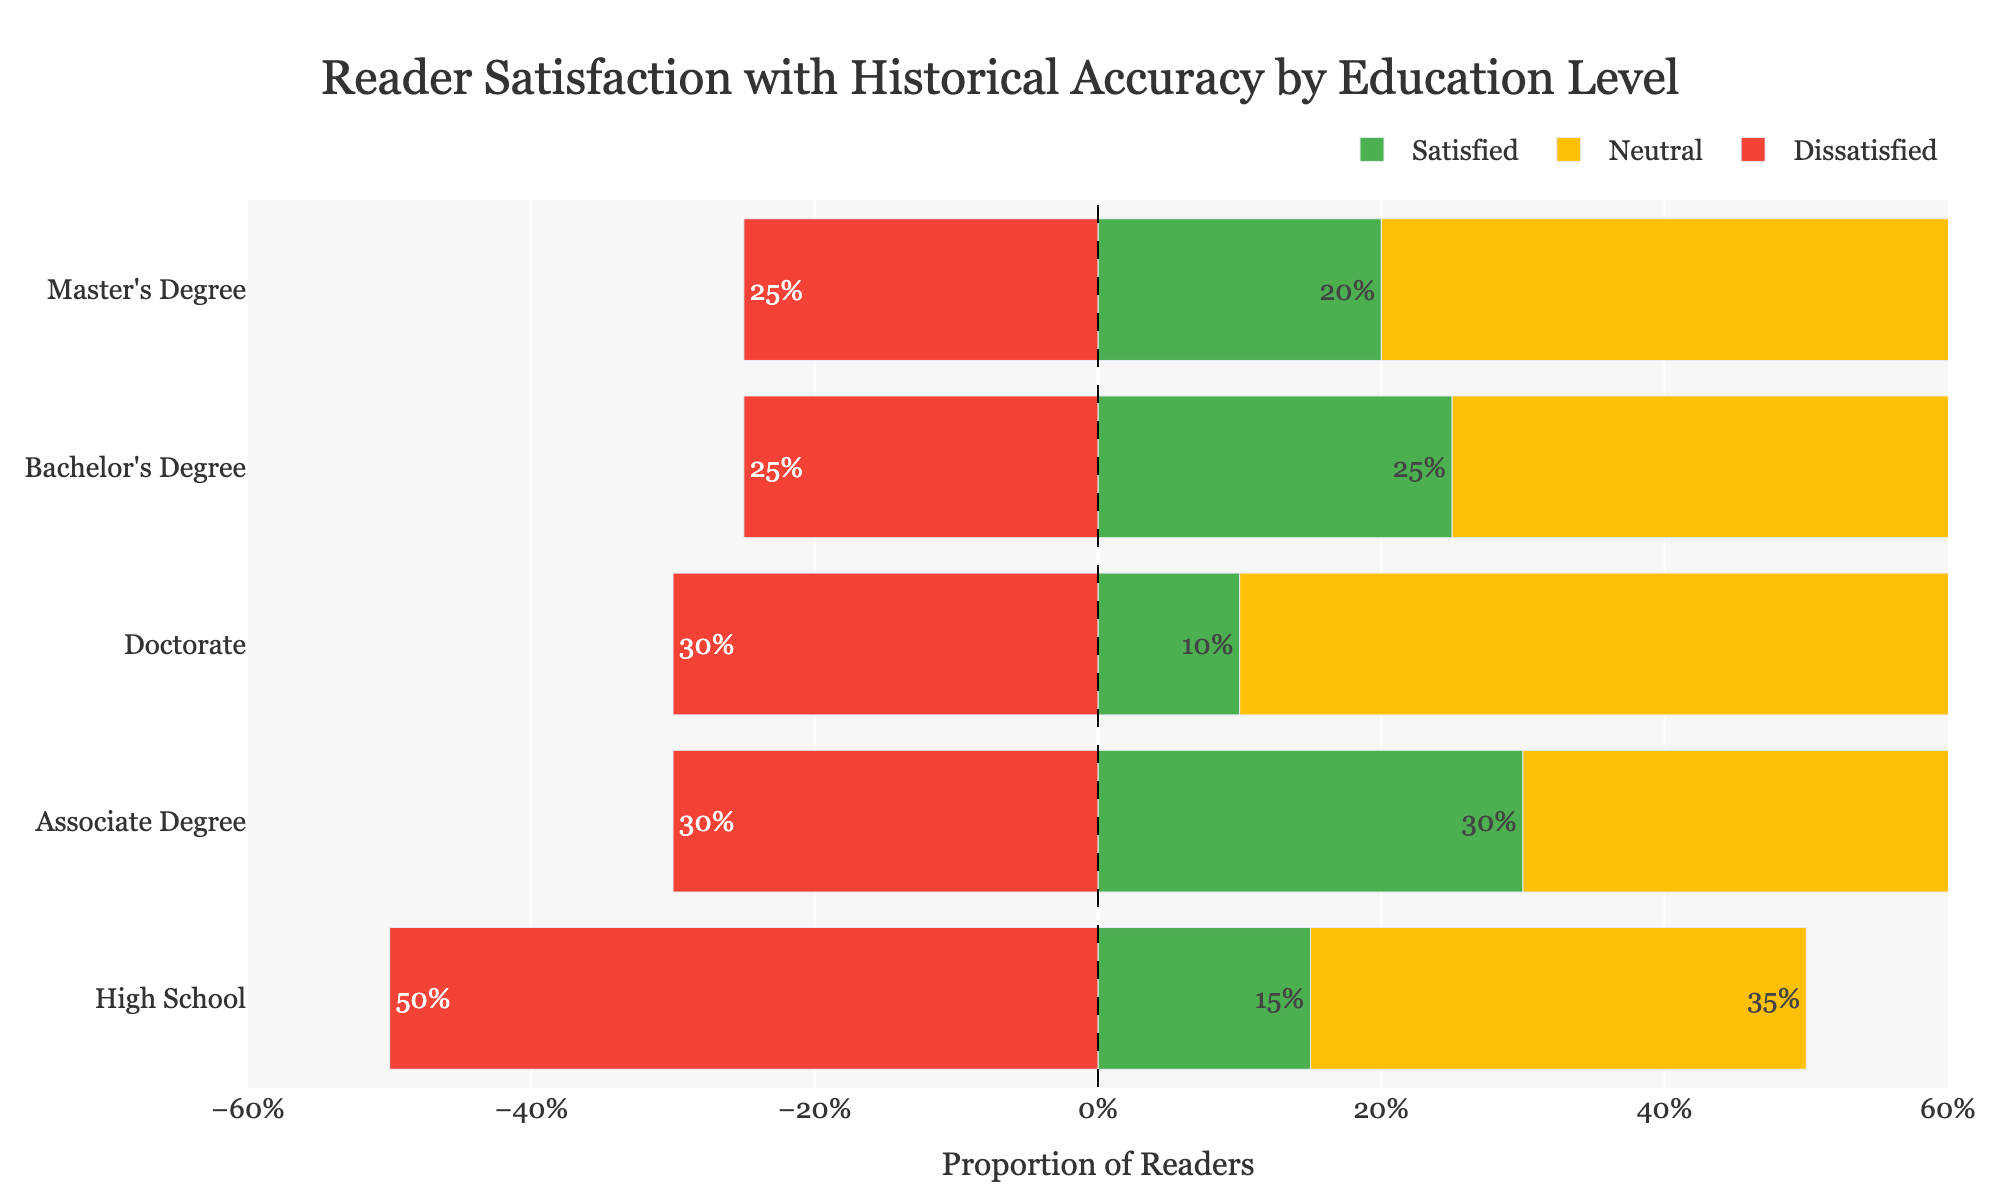What education level has the highest proportion of readers satisfied with historical accuracy? Look at the green bars representing "Satisfied" for each education level and identify the tallest bar. The tallest bar is for the Doctorate level.
Answer: Doctorate Which education level has the highest dissatisfaction with historical accuracy? The red bars represent "Dissatisfied." The longest red bar corresponds to the High School education level.
Answer: High School Is there any education level where the proportion of neutral readers is higher than 50%? Check the yellow bars representing "Neutral." Only at the Master's Degree and Doctorate levels do the yellow bars exceed 50%.
Answer: Yes, Master's Degree and Doctorate How does the proportion of satisfied readers with a Bachelor's Degree compare to those with an Associate Degree? Compare the lengths of the green bars for Bachelor's Degree and Associate Degree. The Bachelor's Degree has a shorter green bar (25%) compared to the Associate Degree (30%).
Answer: Bachelor's Degree is less Sum up the proportions of satisfied and neutral readers for the Master's Degree. The green bar for "Satisfied" is 20% and the yellow bar for "Neutral" is 55%. Summing these gives 20% + 55% = 75%.
Answer: 75% What is the average proportion of dissatisfied readers across all education levels? Add the proportions of dissatisfied readers, then divide by the number of education levels: (50% + 30% + 25% + 25% + 30%) / 5 = 32%.
Answer: 32% Which education level has the smallest proportion of neutral readers? The yellow bars represent "Neutral." The shortest yellow bar corresponds to the High School level (35%).
Answer: High School Compare the proportions of satisfied and dissatisfied readers with a High School education. Which is greater? Look at the green bar for "Satisfied" and the red bar for "Dissatisfied" for High School. The "Dissatisfied" bar (50%) is greater than "Satisfied" (15%).
Answer: Dissatisfied is greater For readers with a Doctorate, what is the combined proportion of dissatisfied and satisfied readers? For the Doctorate level, "Dissatisfied" is 30% and "Satisfied" is 10%. Add these proportions: 30% + 10% = 40%.
Answer: 40% Among readers with a Master's Degree, what is the difference between the proportions of neutral and dissatisfied readers? Neutral proportion is 55%, and Dissatisfied proportion is 25% for the Master's Degree. Subtract dissatisfied from neutral: 55% - 25% = 30%.
Answer: 30% 